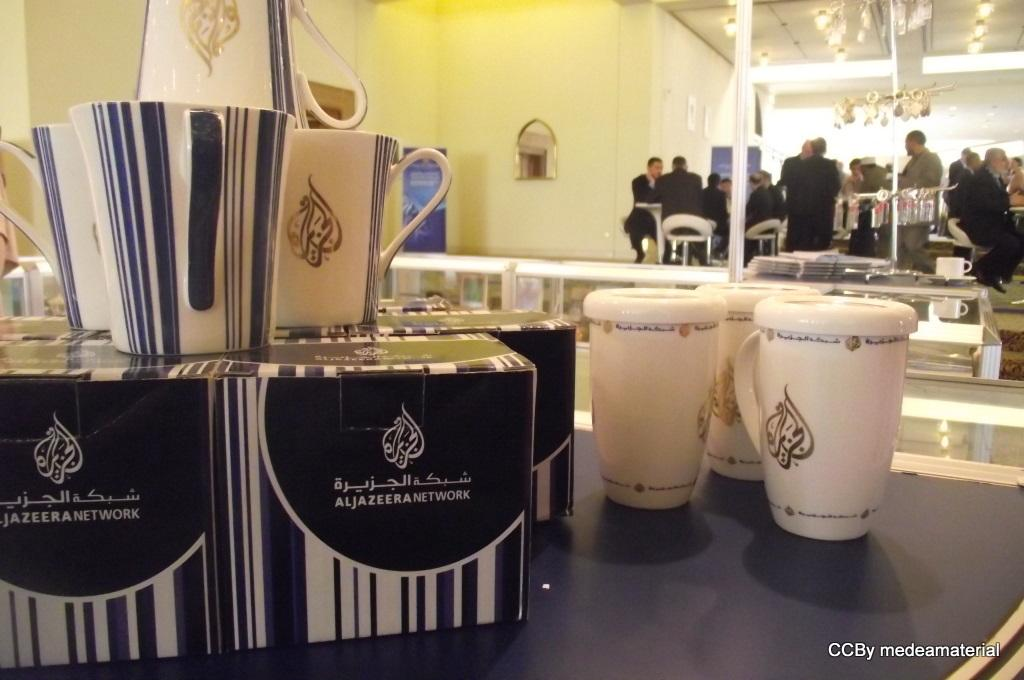Provide a one-sentence caption for the provided image. Several items including some boxes with foreign writing on them and some porcelain cups with the writing sit on top of a counter in a store. 